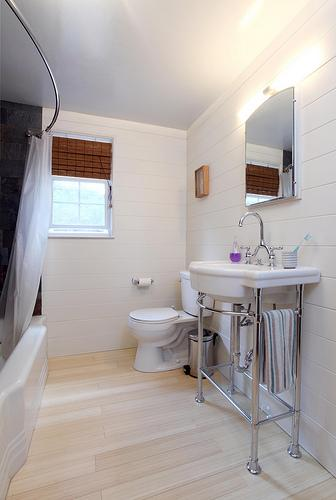Can you tell any bathroom accessories located near the toilet? If so, list them. A silver and black small trash can and a white roll of toilet paper. Count the number of mirrors present in the image. There is one mirror present in the image. Briefly describe the setting of the image. A bathroom with a white toilet, bathtub, sink, and striped towel, a silver trash can, hardwood floors, and a window with bamboo shades. What type of flooring is present in the image? Light brown hardwood flooring is present in the image. Mention any two items you could find above or around the sink. A rounded rectangular mirror and a silver faucet with handles. What type of object is stored in a ceramic container in the scene? A toothbrush is stored in a ceramic container. What can you see above the toilet in the image? A wooden framed image is present above the toilet. Analyze the emotion or sentiment conveyed by the image. The image conveys a feeling of cleanliness and simplicity in a well-organized bathroom space. Describe the appearance of the shower curtain in the image. The shower curtain is a white plastic curtain hanging on a curved silver rod. Provide a description of the window shade present in the bathroom. There is a roll-up bamboo window shade in the window, which is wooden and has black string. Describe the appearance of the towel on the side of the vanity in diverse ways. It is a white towel with stripes, and it's hanging on a metal rack under the sink. Is the toothbrush in the ceramic container red? The toothbrush is actually clear and green, not red.  Examine the image and describe the flooring. The flooring is light brown hardwood. Does the wooden window shade have blue strings? The wooden window shade has black strings, not blue.  Is the roll of toilet paper on the dispenser pink? The roll of toilet paper is white, not pink.  How does the image portray the window in the bathroom? A window on the bathroom wall with a wooden and black string window shade What is the color of the toothbrush in the image? Blue Describe the appearance of the mirror in the bathroom. Rounded rectangular mirror above the sink Find the color and type of the trash can in the image. Silver and black, small trashcan. Is the faucet and handles made of gold? The faucet and handles are silver, not gold.  How does the image present the toilet paper? The image shows a white roll of toilet paper on a dispenser. Find the material and color of the trash can in the image. The material is silver and it is a small silver trash can. Identify the color and position of the mirror in the image. The mirror is above the sink and it is a rounded rectangular mirror. Which of these items is in a ceramic container in the image? b) Toothbrush What is the material of the bathtub in the bathroom? White porcelain Is the hardwood flooring in the bathroom dark brown? The hardwood flooring is light brown, not dark brown. In the image, identify the object hanged next to the porcelain sink. A striped towel hanging on a metal rack under the sink. Which object is rolled up in the window? Bamboo window shade Describe the appearance of the towel on the side of the vanity. It is a white striped towel. What material is the flooring in the bathroom made of? Light brown hardwood What type of curtain is present in the bathroom? b) Plastic How does the image portray the toothbrush? A clear and green toothbrush in a ceramic container. What is the color of the soap in the clear bottle? Purple Does the mirror on the wall have a floral frame? The mirror has a rectangular frame, not a floral one.  What is the color and style of the shower curtain? White, plastic shower curtain Examine the image and describe the window shade. It is a wooden and black string window shade. 